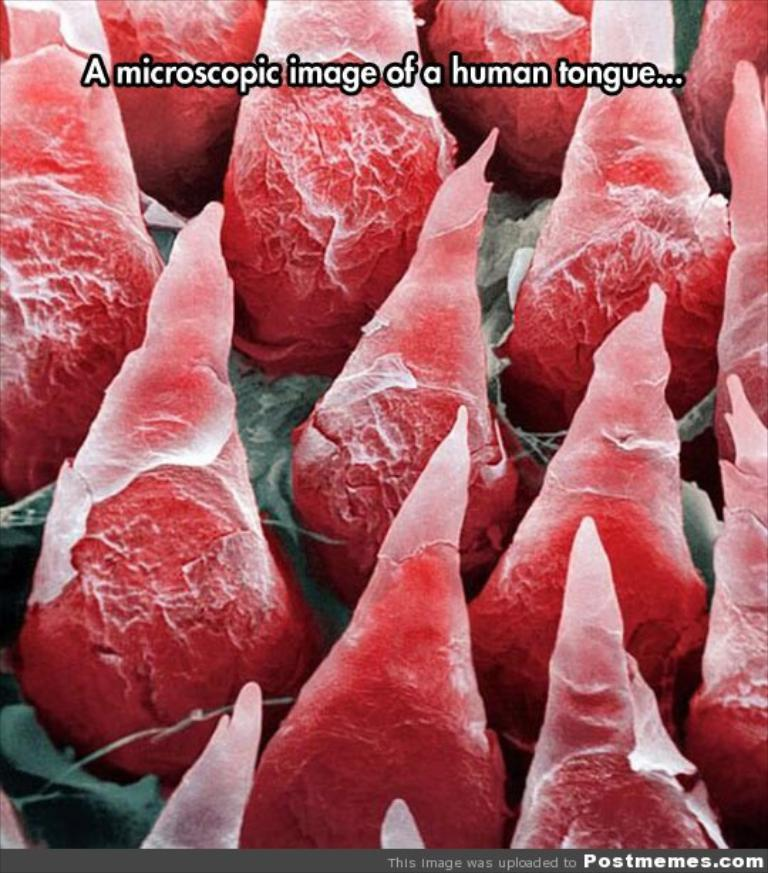What is the main object in the image? There is a microscope in the image. What is the microscope focused on? The microscope is focused on a human tongue. Is there any additional information or marking in the image? Yes, there is a watermark at the bottom of the image. How many children are playing with the cabbage in the image? There are no children or cabbage present in the image; it features a microscope focused on a human tongue. 